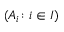<formula> <loc_0><loc_0><loc_500><loc_500>( A _ { i } \colon i \in I )</formula> 